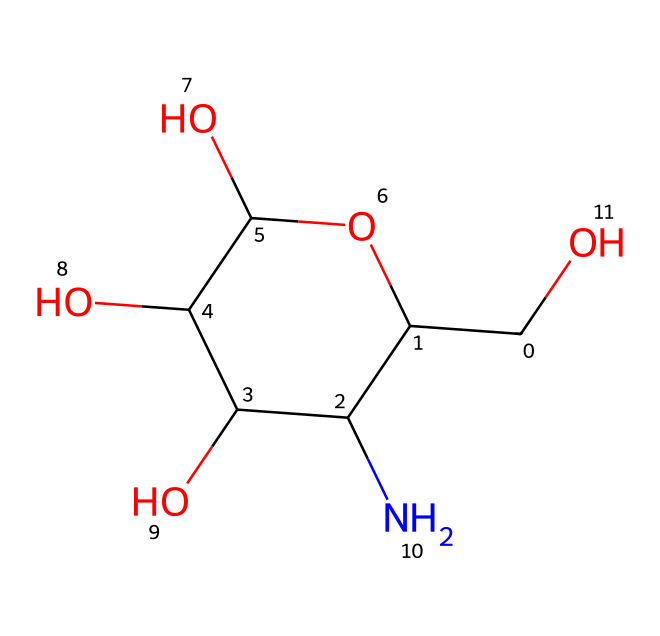What is the chemical name of this compound? The SMILES representation corresponds to a molecule known as glucosamine, which is commonly used in joint health supplements. This can be inferred from the presence of specific functional groups and connections unique to glucosamine.
Answer: glucosamine How many carbon (C) atoms are present in the structure? By analyzing the SMILES structure, we can count the number of carbon atoms present. The representation has a total of 6 carbon atoms indicated in the chain and rings when we account for all occurrences of 'C'.
Answer: 6 What is the total number of hydroxyl (–OH) groups in this compound? The structure reveals three –OH functional groups, which are typical in glucosamine. We can identify these by looking for instances of 'O' that are connected to carbon atoms without forming a carbonyl.
Answer: 3 Does this compound contain any nitrogen (N) atoms? Yes, the structure clearly contains one nitrogen atom, as indicated by the presence of 'N' in the SMILES representation. This is crucial for its classification as an amino sugar.
Answer: 1 Is glucosamine a monosaccharide or polysaccharide? Glucosamine is classified as a monosaccharide due to its structure, which consists of a single sugar unit rather than multiple sugar units combined, which would form a polysaccharide.
Answer: monosaccharide What property does the nitrogen (N) atom confer to this structure? The presence of the nitrogen atom suggests that this molecule functions as an amino sugar, which enhances its role in joint health supplements, as it can contribute to cartilage repair and maintenance.
Answer: amino sugar How is this compound typically labeled in dietary supplement ingredients? Glucosamine is often labeled as "glucosamine sulfate" or "glucosamine hydrochloride" in dietary supplements, reflecting its common forms and usage in health products aimed at joint support.
Answer: glucosamine sulfate or glucosamine hydrochloride 